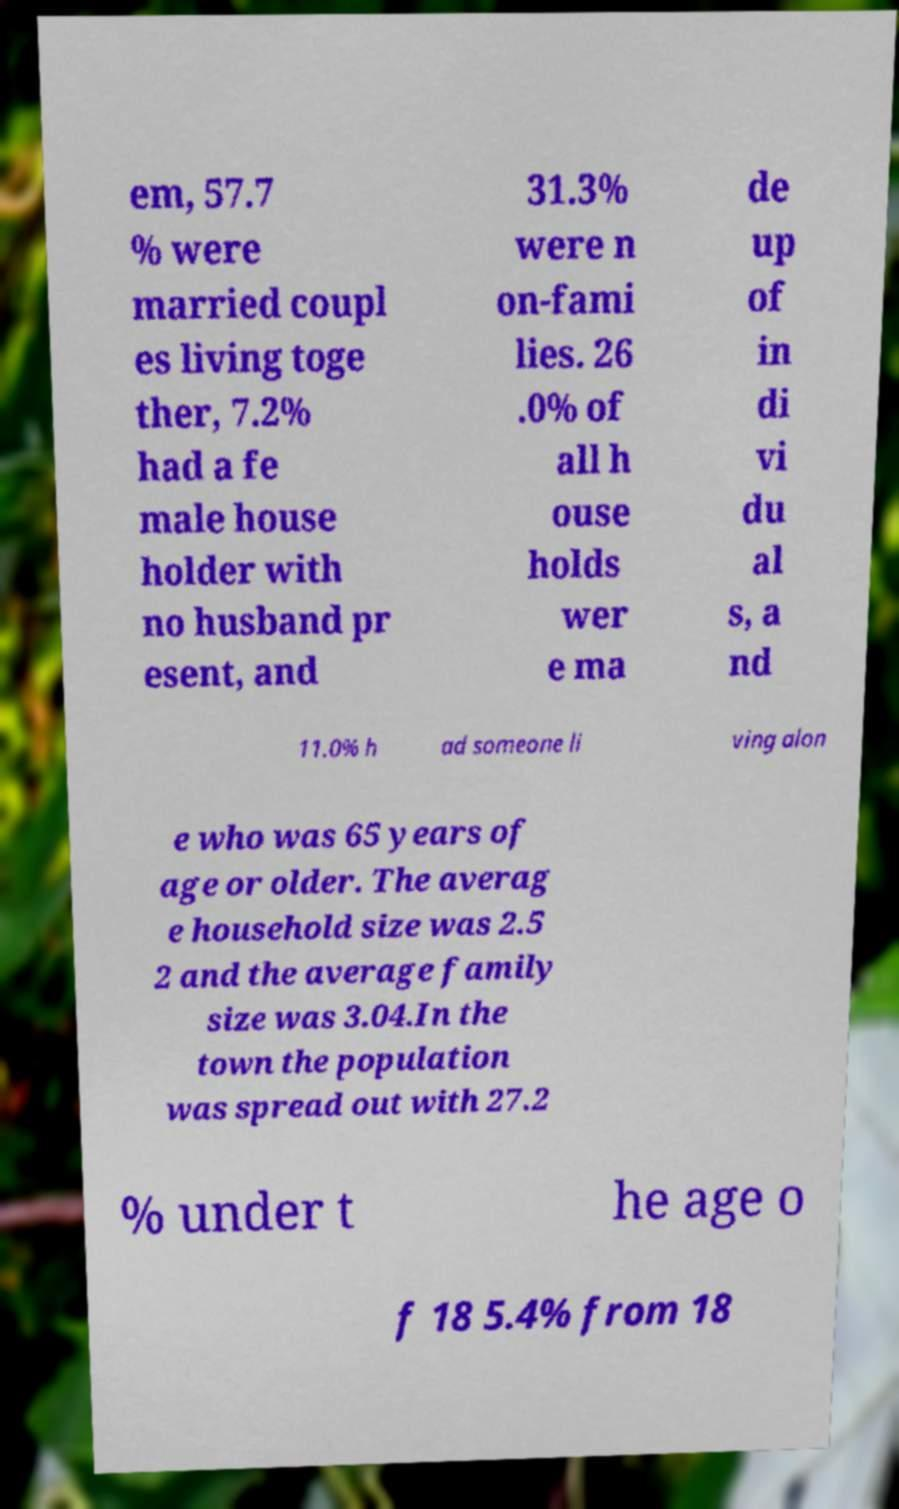Please read and relay the text visible in this image. What does it say? em, 57.7 % were married coupl es living toge ther, 7.2% had a fe male house holder with no husband pr esent, and 31.3% were n on-fami lies. 26 .0% of all h ouse holds wer e ma de up of in di vi du al s, a nd 11.0% h ad someone li ving alon e who was 65 years of age or older. The averag e household size was 2.5 2 and the average family size was 3.04.In the town the population was spread out with 27.2 % under t he age o f 18 5.4% from 18 